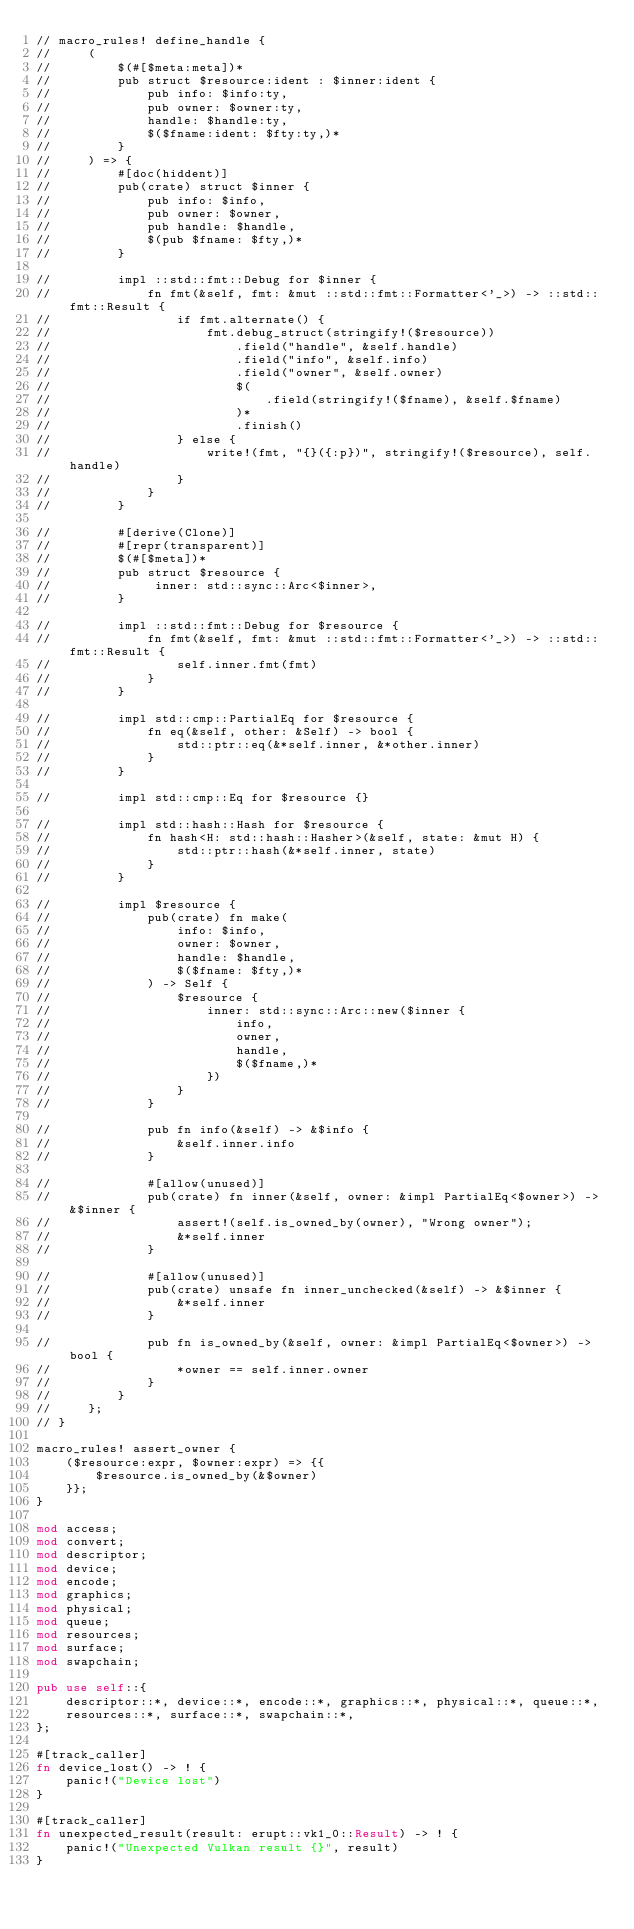<code> <loc_0><loc_0><loc_500><loc_500><_Rust_>// macro_rules! define_handle {
//     (
//         $(#[$meta:meta])*
//         pub struct $resource:ident : $inner:ident {
//             pub info: $info:ty,
//             pub owner: $owner:ty,
//             handle: $handle:ty,
//             $($fname:ident: $fty:ty,)*
//         }
//     ) => {
//         #[doc(hiddent)]
//         pub(crate) struct $inner {
//             pub info: $info,
//             pub owner: $owner,
//             pub handle: $handle,
//             $(pub $fname: $fty,)*
//         }

//         impl ::std::fmt::Debug for $inner {
//             fn fmt(&self, fmt: &mut ::std::fmt::Formatter<'_>) -> ::std::fmt::Result {
//                 if fmt.alternate() {
//                     fmt.debug_struct(stringify!($resource))
//                         .field("handle", &self.handle)
//                         .field("info", &self.info)
//                         .field("owner", &self.owner)
//                         $(
//                             .field(stringify!($fname), &self.$fname)
//                         )*
//                         .finish()
//                 } else {
//                     write!(fmt, "{}({:p})", stringify!($resource), self.handle)
//                 }
//             }
//         }

//         #[derive(Clone)]
//         #[repr(transparent)]
//         $(#[$meta])*
//         pub struct $resource {
//              inner: std::sync::Arc<$inner>,
//         }

//         impl ::std::fmt::Debug for $resource {
//             fn fmt(&self, fmt: &mut ::std::fmt::Formatter<'_>) -> ::std::fmt::Result {
//                 self.inner.fmt(fmt)
//             }
//         }

//         impl std::cmp::PartialEq for $resource {
//             fn eq(&self, other: &Self) -> bool {
//                 std::ptr::eq(&*self.inner, &*other.inner)
//             }
//         }

//         impl std::cmp::Eq for $resource {}

//         impl std::hash::Hash for $resource {
//             fn hash<H: std::hash::Hasher>(&self, state: &mut H) {
//                 std::ptr::hash(&*self.inner, state)
//             }
//         }

//         impl $resource {
//             pub(crate) fn make(
//                 info: $info,
//                 owner: $owner,
//                 handle: $handle,
//                 $($fname: $fty,)*
//             ) -> Self {
//                 $resource {
//                     inner: std::sync::Arc::new($inner {
//                         info,
//                         owner,
//                         handle,
//                         $($fname,)*
//                     })
//                 }
//             }

//             pub fn info(&self) -> &$info {
//                 &self.inner.info
//             }

//             #[allow(unused)]
//             pub(crate) fn inner(&self, owner: &impl PartialEq<$owner>) -> &$inner {
//                 assert!(self.is_owned_by(owner), "Wrong owner");
//                 &*self.inner
//             }

//             #[allow(unused)]
//             pub(crate) unsafe fn inner_unchecked(&self) -> &$inner {
//                 &*self.inner
//             }

//             pub fn is_owned_by(&self, owner: &impl PartialEq<$owner>) -> bool {
//                 *owner == self.inner.owner
//             }
//         }
//     };
// }

macro_rules! assert_owner {
    ($resource:expr, $owner:expr) => {{
        $resource.is_owned_by(&$owner)
    }};
}

mod access;
mod convert;
mod descriptor;
mod device;
mod encode;
mod graphics;
mod physical;
mod queue;
mod resources;
mod surface;
mod swapchain;

pub use self::{
    descriptor::*, device::*, encode::*, graphics::*, physical::*, queue::*,
    resources::*, surface::*, swapchain::*,
};

#[track_caller]
fn device_lost() -> ! {
    panic!("Device lost")
}

#[track_caller]
fn unexpected_result(result: erupt::vk1_0::Result) -> ! {
    panic!("Unexpected Vulkan result {}", result)
}
</code> 